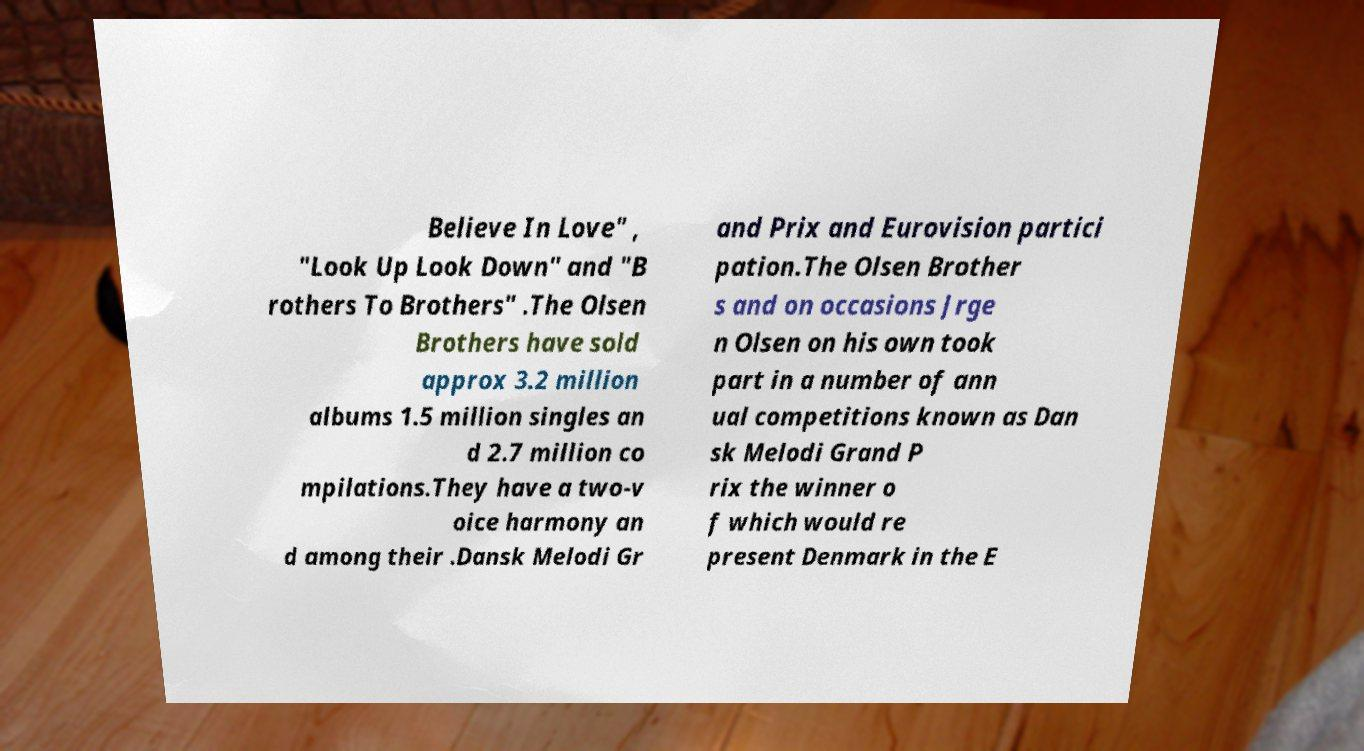What messages or text are displayed in this image? I need them in a readable, typed format. Believe In Love" , "Look Up Look Down" and "B rothers To Brothers" .The Olsen Brothers have sold approx 3.2 million albums 1.5 million singles an d 2.7 million co mpilations.They have a two-v oice harmony an d among their .Dansk Melodi Gr and Prix and Eurovision partici pation.The Olsen Brother s and on occasions Jrge n Olsen on his own took part in a number of ann ual competitions known as Dan sk Melodi Grand P rix the winner o f which would re present Denmark in the E 